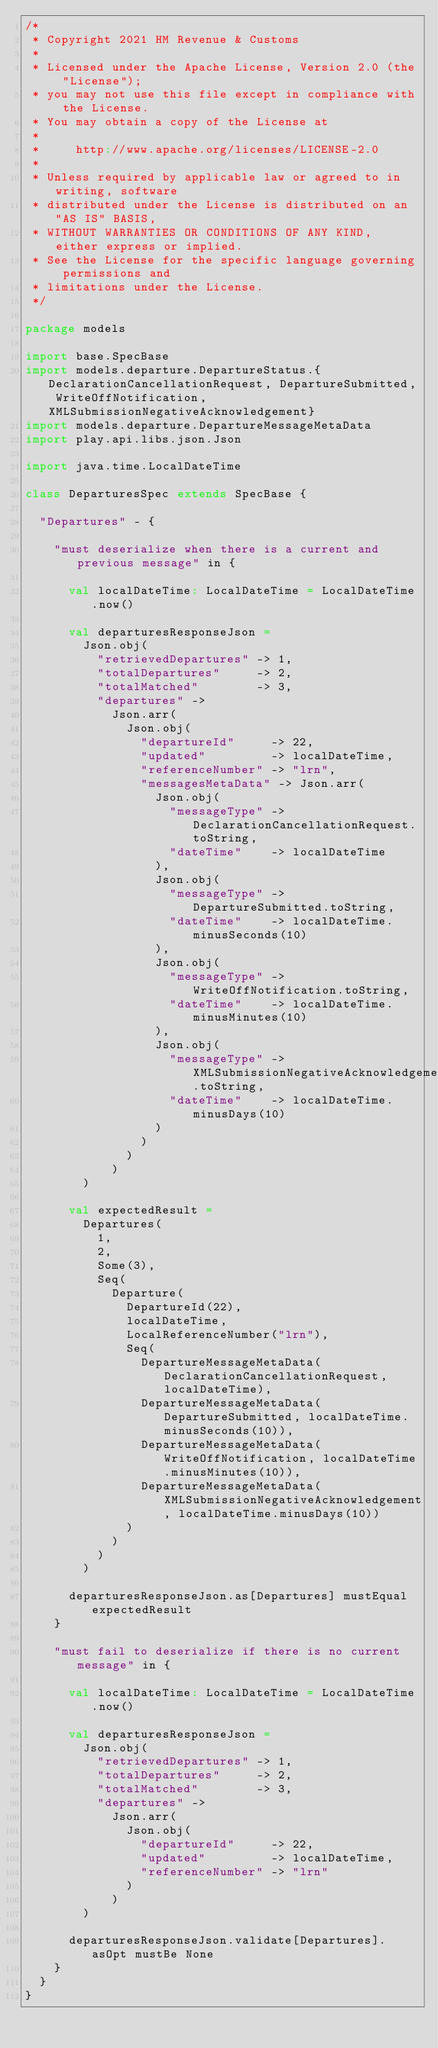Convert code to text. <code><loc_0><loc_0><loc_500><loc_500><_Scala_>/*
 * Copyright 2021 HM Revenue & Customs
 *
 * Licensed under the Apache License, Version 2.0 (the "License");
 * you may not use this file except in compliance with the License.
 * You may obtain a copy of the License at
 *
 *     http://www.apache.org/licenses/LICENSE-2.0
 *
 * Unless required by applicable law or agreed to in writing, software
 * distributed under the License is distributed on an "AS IS" BASIS,
 * WITHOUT WARRANTIES OR CONDITIONS OF ANY KIND, either express or implied.
 * See the License for the specific language governing permissions and
 * limitations under the License.
 */

package models

import base.SpecBase
import models.departure.DepartureStatus.{DeclarationCancellationRequest, DepartureSubmitted, WriteOffNotification, XMLSubmissionNegativeAcknowledgement}
import models.departure.DepartureMessageMetaData
import play.api.libs.json.Json

import java.time.LocalDateTime

class DeparturesSpec extends SpecBase {

  "Departures" - {

    "must deserialize when there is a current and previous message" in {

      val localDateTime: LocalDateTime = LocalDateTime.now()

      val departuresResponseJson =
        Json.obj(
          "retrievedDepartures" -> 1,
          "totalDepartures"     -> 2,
          "totalMatched"        -> 3,
          "departures" ->
            Json.arr(
              Json.obj(
                "departureId"     -> 22,
                "updated"         -> localDateTime,
                "referenceNumber" -> "lrn",
                "messagesMetaData" -> Json.arr(
                  Json.obj(
                    "messageType" -> DeclarationCancellationRequest.toString,
                    "dateTime"    -> localDateTime
                  ),
                  Json.obj(
                    "messageType" -> DepartureSubmitted.toString,
                    "dateTime"    -> localDateTime.minusSeconds(10)
                  ),
                  Json.obj(
                    "messageType" -> WriteOffNotification.toString,
                    "dateTime"    -> localDateTime.minusMinutes(10)
                  ),
                  Json.obj(
                    "messageType" -> XMLSubmissionNegativeAcknowledgement.toString,
                    "dateTime"    -> localDateTime.minusDays(10)
                  )
                )
              )
            )
        )

      val expectedResult =
        Departures(
          1,
          2,
          Some(3),
          Seq(
            Departure(
              DepartureId(22),
              localDateTime,
              LocalReferenceNumber("lrn"),
              Seq(
                DepartureMessageMetaData(DeclarationCancellationRequest, localDateTime),
                DepartureMessageMetaData(DepartureSubmitted, localDateTime.minusSeconds(10)),
                DepartureMessageMetaData(WriteOffNotification, localDateTime.minusMinutes(10)),
                DepartureMessageMetaData(XMLSubmissionNegativeAcknowledgement, localDateTime.minusDays(10))
              )
            )
          )
        )

      departuresResponseJson.as[Departures] mustEqual expectedResult
    }

    "must fail to deserialize if there is no current message" in {

      val localDateTime: LocalDateTime = LocalDateTime.now()

      val departuresResponseJson =
        Json.obj(
          "retrievedDepartures" -> 1,
          "totalDepartures"     -> 2,
          "totalMatched"        -> 3,
          "departures" ->
            Json.arr(
              Json.obj(
                "departureId"     -> 22,
                "updated"         -> localDateTime,
                "referenceNumber" -> "lrn"
              )
            )
        )

      departuresResponseJson.validate[Departures].asOpt mustBe None
    }
  }
}
</code> 